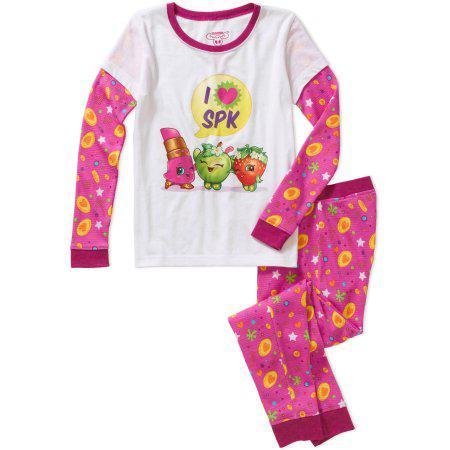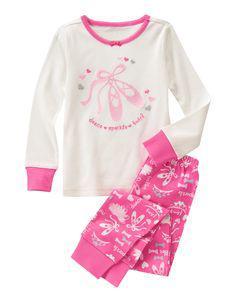The first image is the image on the left, the second image is the image on the right. Assess this claim about the two images: "There is one pair of shorts and one pair of pants.". Correct or not? Answer yes or no. No. The first image is the image on the left, the second image is the image on the right. Given the left and right images, does the statement "a pair of pajamas has short sleeves and long pants" hold true? Answer yes or no. No. 